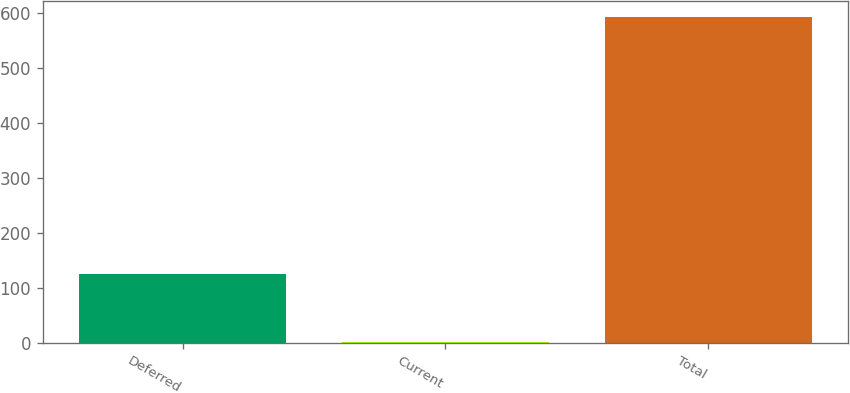Convert chart to OTSL. <chart><loc_0><loc_0><loc_500><loc_500><bar_chart><fcel>Deferred<fcel>Current<fcel>Total<nl><fcel>125<fcel>1<fcel>593<nl></chart> 